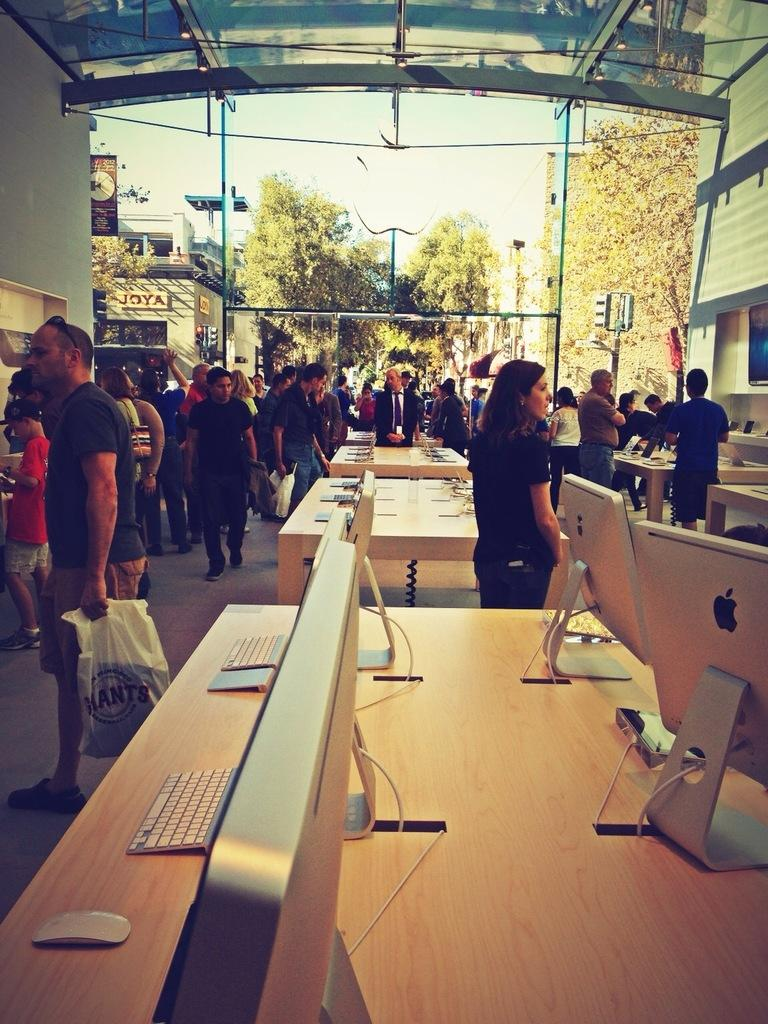What is happening on the road in the image? There are people moving on the road in the image. What can be seen on the table in the image? Laptops are placed on the table in the image. What is visible in the background of the image? There are trees and buildings visible in the background of the image. What type of advice is being given by the scarf in the image? There is no scarf present in the image, and therefore no advice can be given by it. What class is being taught at the table in the image? There is no class being taught in the image; the table has laptops placed on it. 